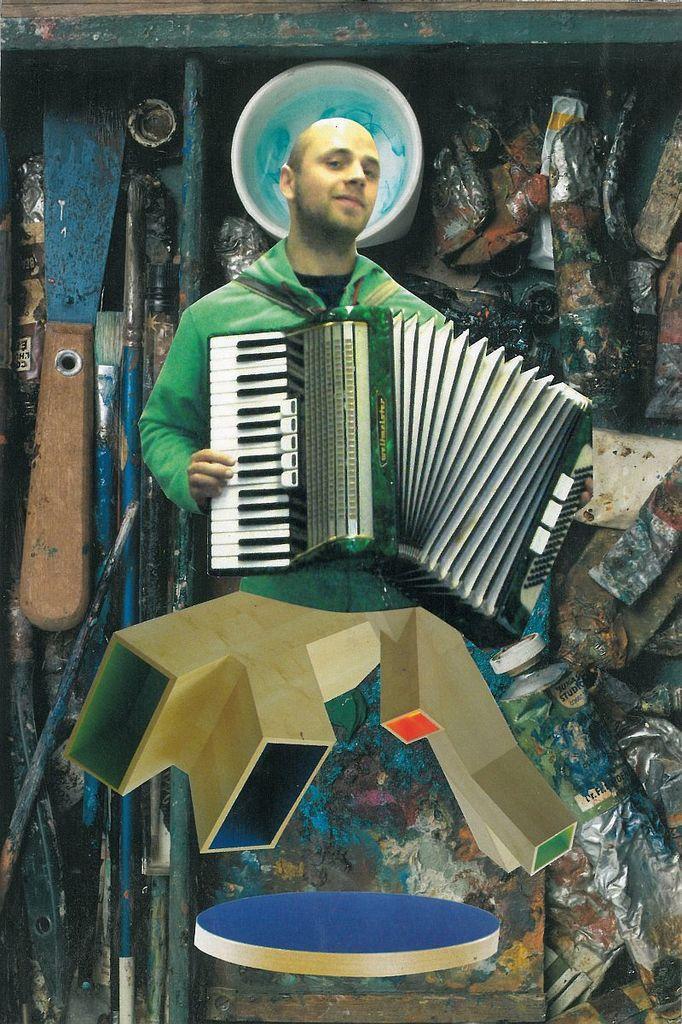Please provide a concise description of this image. This picture is an edited image. In this image we can see one man with a smiling face, holding a musical instrument and playing. There are some objects in the background and two wooden objects in the middle of the image. 